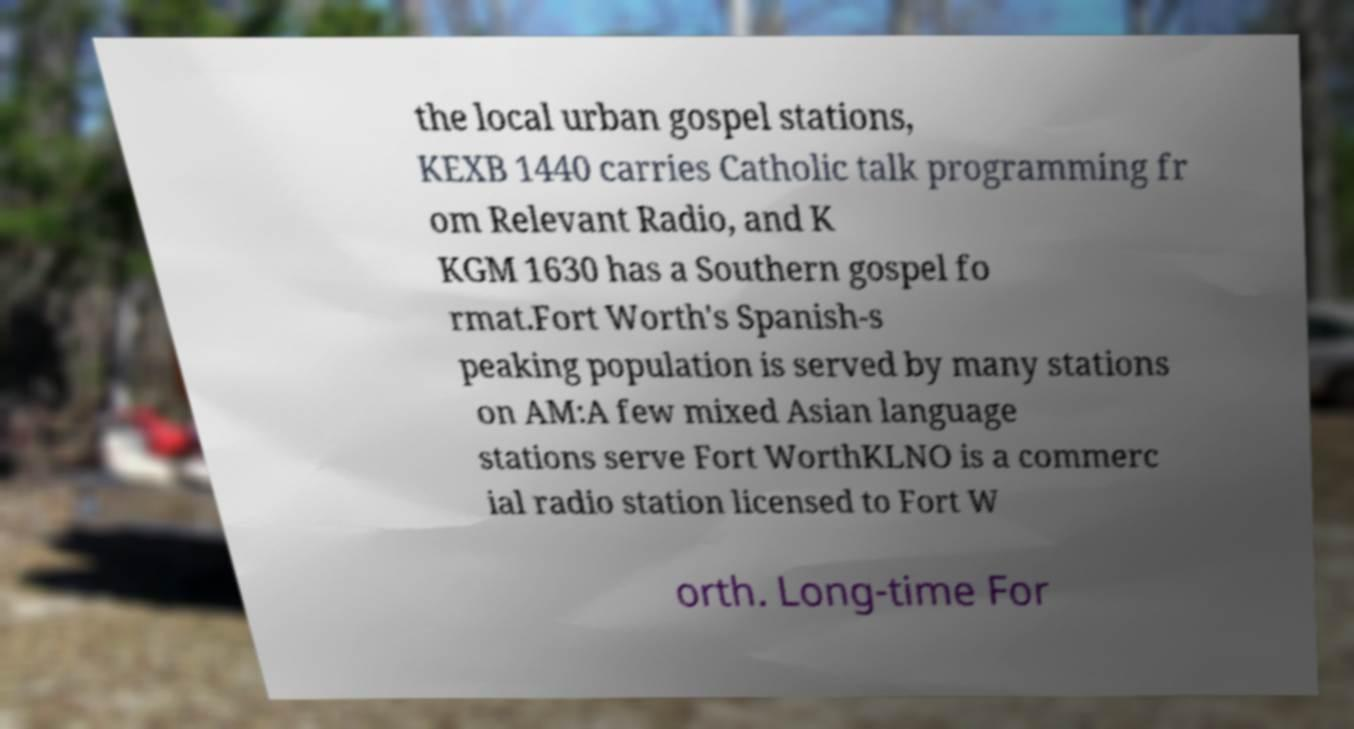Can you accurately transcribe the text from the provided image for me? the local urban gospel stations, KEXB 1440 carries Catholic talk programming fr om Relevant Radio, and K KGM 1630 has a Southern gospel fo rmat.Fort Worth's Spanish-s peaking population is served by many stations on AM:A few mixed Asian language stations serve Fort WorthKLNO is a commerc ial radio station licensed to Fort W orth. Long-time For 